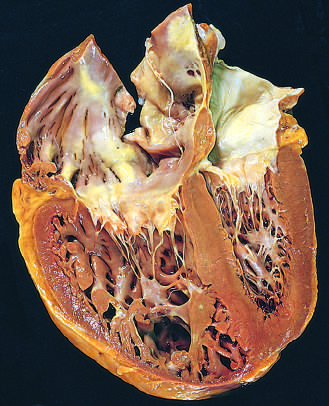has acute viral hepatitis been distorted by the enlarged right ventricle?
Answer the question using a single word or phrase. No 